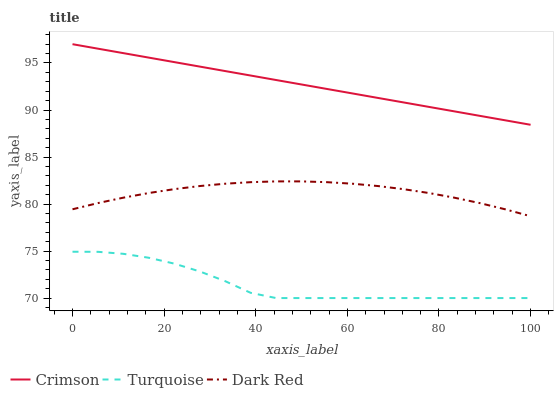Does Turquoise have the minimum area under the curve?
Answer yes or no. Yes. Does Crimson have the maximum area under the curve?
Answer yes or no. Yes. Does Dark Red have the minimum area under the curve?
Answer yes or no. No. Does Dark Red have the maximum area under the curve?
Answer yes or no. No. Is Crimson the smoothest?
Answer yes or no. Yes. Is Turquoise the roughest?
Answer yes or no. Yes. Is Dark Red the smoothest?
Answer yes or no. No. Is Dark Red the roughest?
Answer yes or no. No. Does Turquoise have the lowest value?
Answer yes or no. Yes. Does Dark Red have the lowest value?
Answer yes or no. No. Does Crimson have the highest value?
Answer yes or no. Yes. Does Dark Red have the highest value?
Answer yes or no. No. Is Turquoise less than Crimson?
Answer yes or no. Yes. Is Crimson greater than Turquoise?
Answer yes or no. Yes. Does Turquoise intersect Crimson?
Answer yes or no. No. 